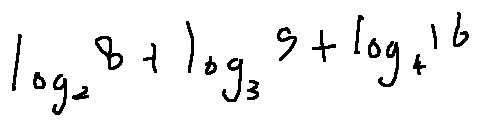Convert formula to latex. <formula><loc_0><loc_0><loc_500><loc_500>\log _ { 2 } 8 + \log _ { 3 } 9 + \log _ { 4 } 1 6</formula> 